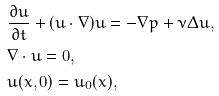Convert formula to latex. <formula><loc_0><loc_0><loc_500><loc_500>& \frac { \partial u } { \partial t } + ( u \cdot \nabla ) u = - \nabla p + \nu \Delta u , \\ & \nabla \cdot u = 0 , \\ & u ( x , 0 ) = u _ { 0 } ( x ) ,</formula> 